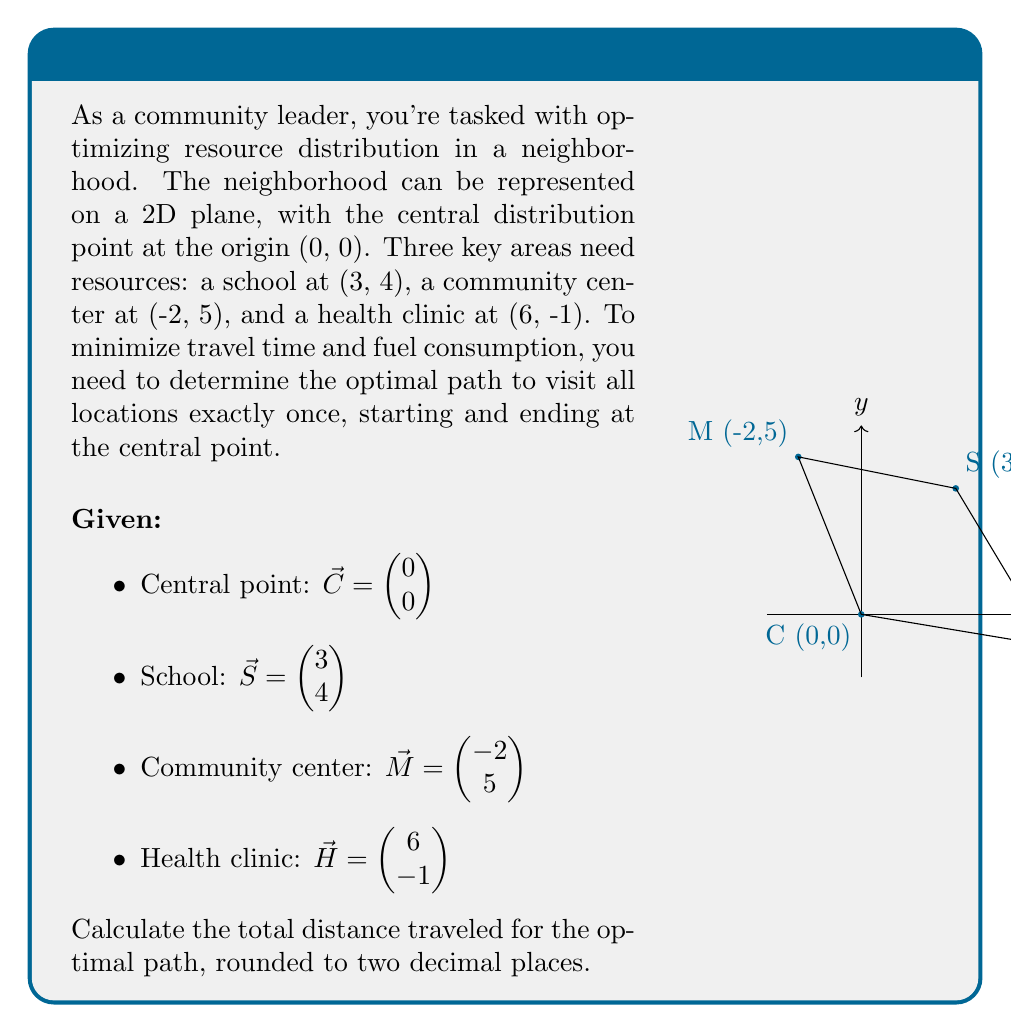Can you answer this question? To solve this problem, we'll use vector operations to calculate distances between points and determine the optimal path. We'll consider all possible paths and choose the one with the shortest total distance.

Step 1: Calculate distances between all points using the distance formula:
$d = \sqrt{(x_2-x_1)^2 + (y_2-y_1)^2}$

$d_{CS} = \sqrt{(3-0)^2 + (4-0)^2} = 5$
$d_{CM} = \sqrt{(-2-0)^2 + (5-0)^2} = \sqrt{29}$
$d_{CH} = \sqrt{(6-0)^2 + (-1-0)^2} = \sqrt{37}$
$d_{SM} = \sqrt{(-2-3)^2 + (5-4)^2} = \sqrt{26}$
$d_{SH} = \sqrt{(6-3)^2 + (-1-4)^2} = \sqrt{34}$
$d_{MH} = \sqrt{(6-(-2))^2 + (-1-5)^2} = \sqrt{116}$

Step 2: Consider all possible paths:
1. C → S → M → H → C
2. C → S → H → M → C
3. C → M → S → H → C
4. C → M → H → S → C
5. C → H → S → M → C
6. C → H → M → S → C

Step 3: Calculate total distance for each path:
1. $5 + \sqrt{26} + \sqrt{34} + \sqrt{37} \approx 22.65$
2. $5 + \sqrt{34} + \sqrt{116} + \sqrt{29} \approx 28.24$
3. $\sqrt{29} + \sqrt{26} + \sqrt{34} + \sqrt{37} \approx 24.18$
4. $\sqrt{29} + \sqrt{116} + \sqrt{34} + 5 \approx 28.24$
5. $\sqrt{37} + \sqrt{34} + \sqrt{26} + \sqrt{29} \approx 24.18$
6. $\sqrt{37} + \sqrt{116} + \sqrt{26} + 5 \approx 28.65$

Step 4: Identify the shortest path:
The optimal path is C → S → M → H → C, with a total distance of approximately 22.65 units.
Answer: 22.65 units 